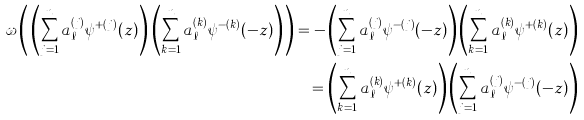<formula> <loc_0><loc_0><loc_500><loc_500>\omega \left ( \, \left ( \sum _ { j = 1 } ^ { n } a _ { \ell } ^ { ( j ) } \psi ^ { + ( j ) } ( z ) \right ) \, \left ( \sum _ { k = 1 } ^ { n } a _ { \ell } ^ { ( k ) } \psi ^ { - ( k ) } ( - z ) \right ) \, \right ) = - \left ( \sum _ { j = 1 } ^ { n } a _ { \ell } ^ { ( j ) } \psi ^ { - ( j ) } ( - z ) \right ) \left ( \sum _ { k = 1 } ^ { n } a _ { \ell } ^ { ( k ) } \psi ^ { + ( k ) } ( z ) \right ) \\ = \left ( \sum _ { k = 1 } ^ { n } a _ { \ell } ^ { ( k ) } \psi ^ { + ( k ) } ( z ) \right ) \left ( \sum _ { j = 1 } ^ { n } a _ { \ell } ^ { ( j ) } \psi ^ { - ( j ) } ( - z ) \right )</formula> 